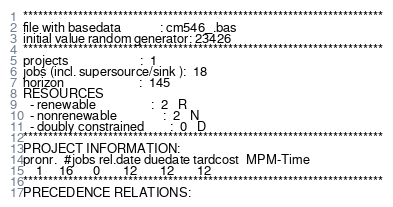<code> <loc_0><loc_0><loc_500><loc_500><_ObjectiveC_>************************************************************************
file with basedata            : cm546_.bas
initial value random generator: 23426
************************************************************************
projects                      :  1
jobs (incl. supersource/sink ):  18
horizon                       :  145
RESOURCES
  - renewable                 :  2   R
  - nonrenewable              :  2   N
  - doubly constrained        :  0   D
************************************************************************
PROJECT INFORMATION:
pronr.  #jobs rel.date duedate tardcost  MPM-Time
    1     16      0       12       12       12
************************************************************************
PRECEDENCE RELATIONS:</code> 